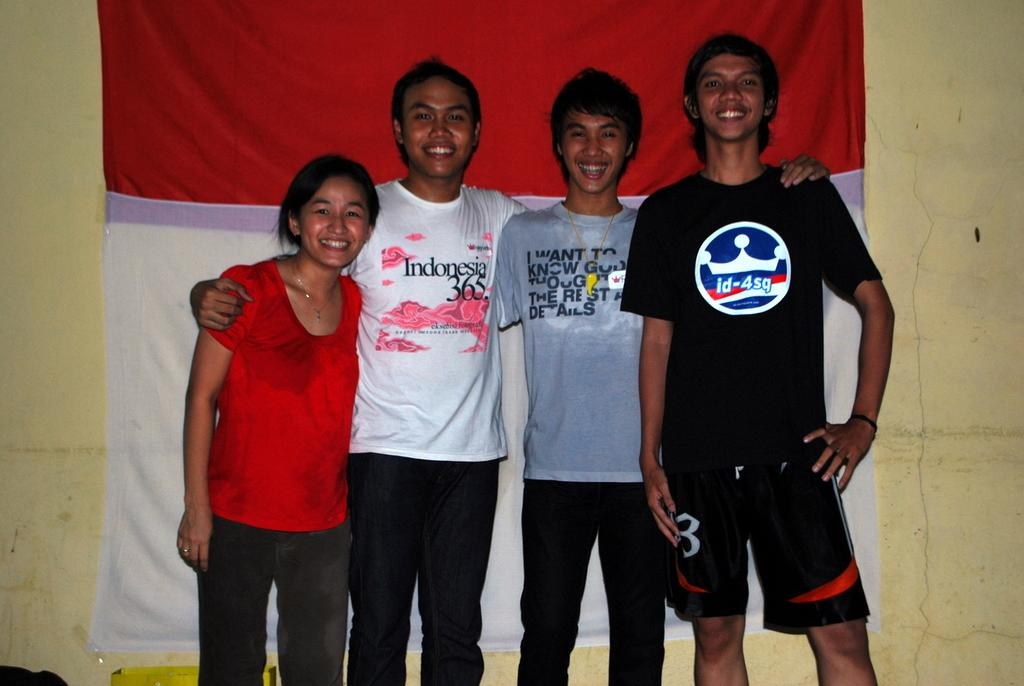Provide a one-sentence caption for the provided image. One of the four smiling friends posing in front of a red and white banner wears an Indonesia 365 t-shirt. 